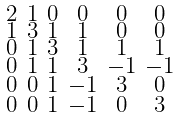<formula> <loc_0><loc_0><loc_500><loc_500>\begin{smallmatrix} 2 & 1 & 0 & 0 & 0 & 0 \\ 1 & 3 & 1 & 1 & 0 & 0 \\ 0 & 1 & 3 & 1 & 1 & 1 \\ 0 & 1 & 1 & 3 & - 1 & - 1 \\ 0 & 0 & 1 & - 1 & 3 & 0 \\ 0 & 0 & 1 & - 1 & 0 & 3 \end{smallmatrix}</formula> 